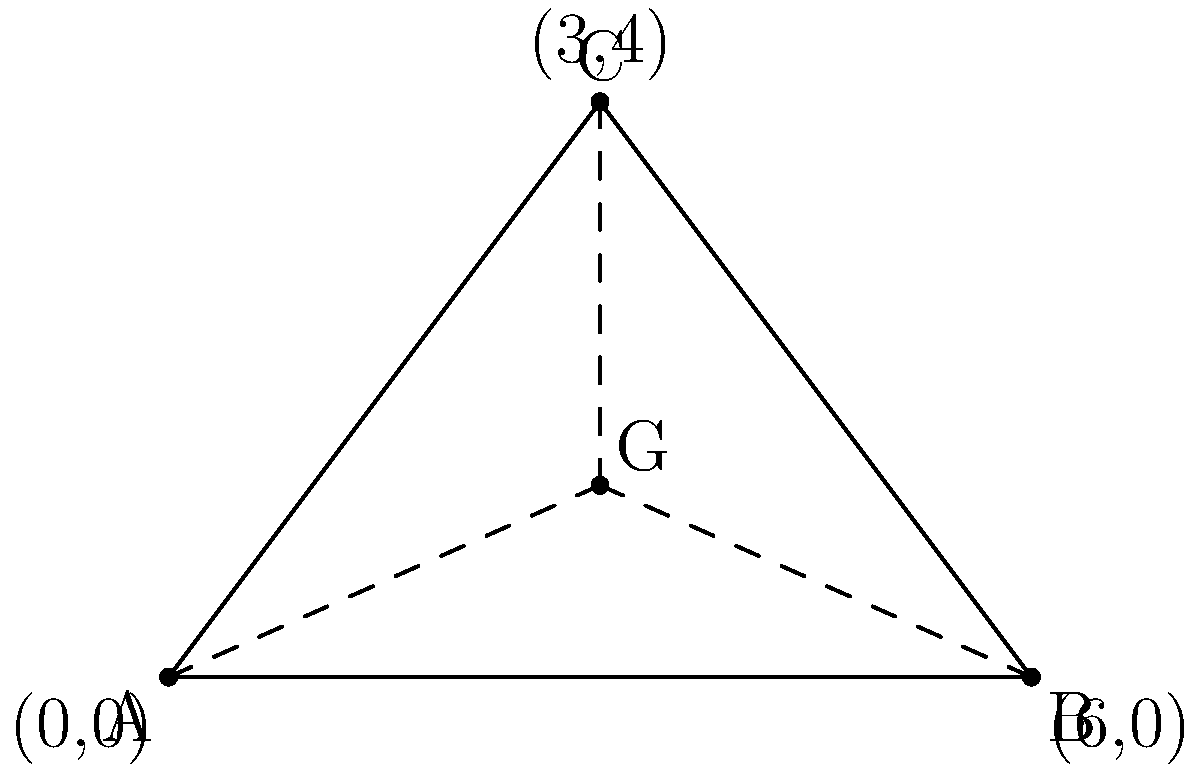In your football playbook, you've drawn a triangular formation with vertices at $A(0,0)$, $B(6,0)$, and $C(3,4)$. To determine the optimal position for the quarterback, you need to find the centroid (G) of this triangle. Calculate the coordinates of the centroid. To find the coordinates of the centroid of a triangle, we can follow these steps:

1) The centroid of a triangle is located at the intersection of its medians, which connect each vertex to the midpoint of the opposite side.

2) The centroid divides each median in a 2:1 ratio, meaning it is located 2/3 of the way from any vertex to the midpoint of the opposite side.

3) We can use the formula for the centroid's coordinates:

   $G_x = \frac{x_A + x_B + x_C}{3}$ and $G_y = \frac{y_A + y_B + y_C}{3}$

   Where $(x_A, y_A)$, $(x_B, y_B)$, and $(x_C, y_C)$ are the coordinates of points A, B, and C respectively.

4) Let's substitute the given coordinates:
   A(0,0), B(6,0), C(3,4)

5) For the x-coordinate:
   $G_x = \frac{0 + 6 + 3}{3} = \frac{9}{3} = 3$

6) For the y-coordinate:
   $G_y = \frac{0 + 0 + 4}{3} = \frac{4}{3}$

Therefore, the coordinates of the centroid G are $(3, \frac{4}{3})$.
Answer: $(3, \frac{4}{3})$ 